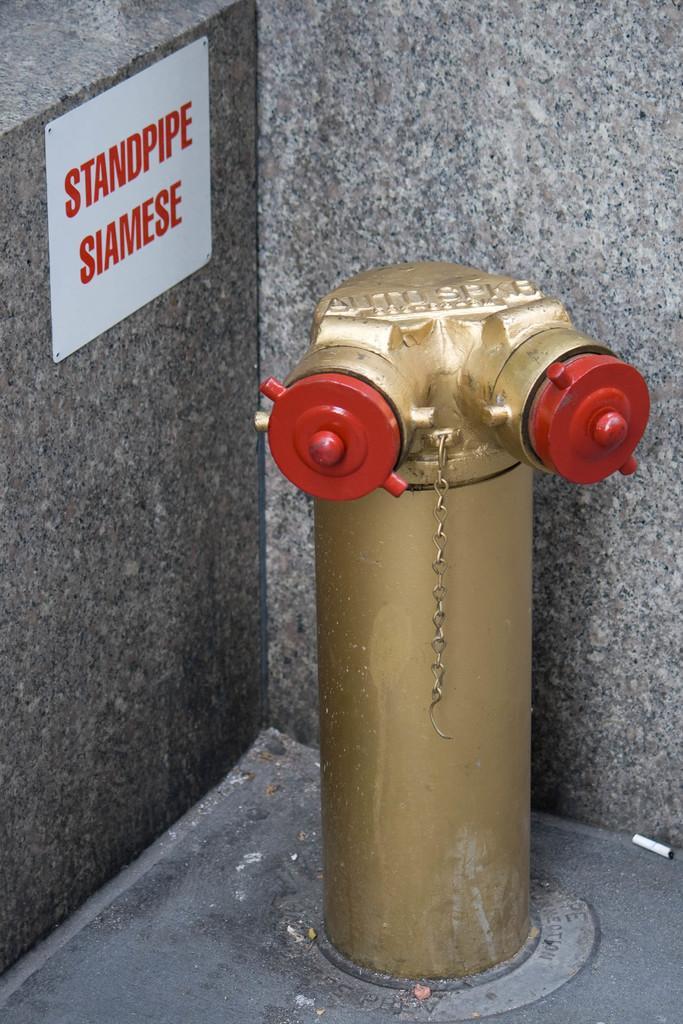Describe this image in one or two sentences. In this image in front there is a water pipe. Behind the water pipe there is a board on the wall. There is some text on the board. 